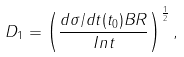<formula> <loc_0><loc_0><loc_500><loc_500>D _ { 1 } = \left ( \frac { d \sigma / d t ( t _ { 0 } ) B R } { I n t } \right ) ^ { \frac { 1 } { 2 } } ,</formula> 